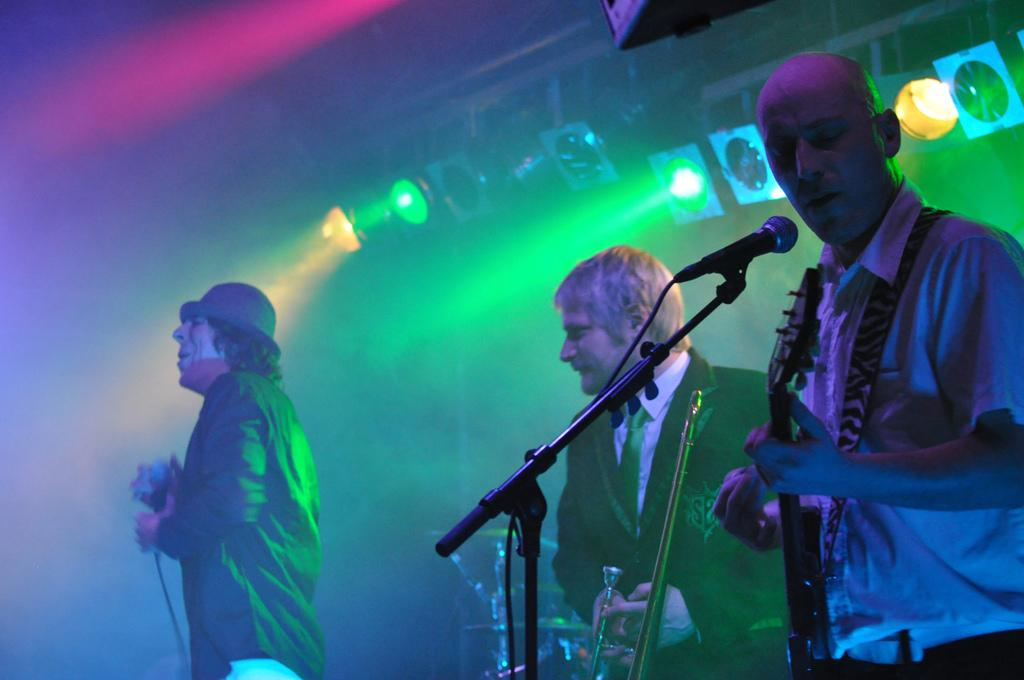What are the people in the image doing? The people in the image are playing musical instruments. How are the people positioned in the image? The people are standing. What equipment is visible in the image? There is a microphone on a stand in the image. What can be seen in the background of the image? Show lights and smoke are visible in the background of the image. What is the aftermath of the bridge collapse in the image? There is no bridge collapse or any related aftermath present in the image. 